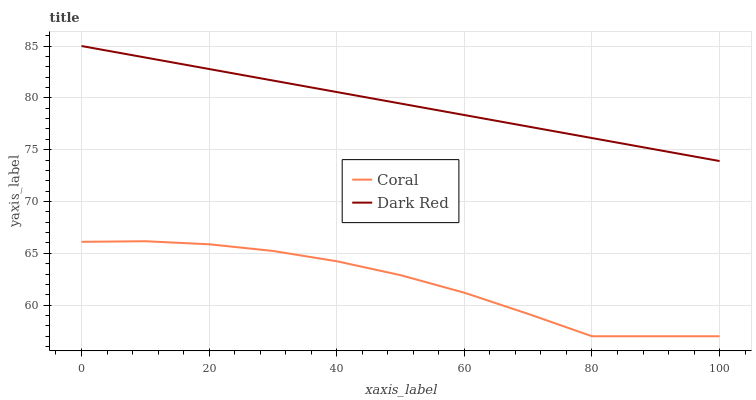Does Coral have the minimum area under the curve?
Answer yes or no. Yes. Does Dark Red have the maximum area under the curve?
Answer yes or no. Yes. Does Coral have the maximum area under the curve?
Answer yes or no. No. Is Dark Red the smoothest?
Answer yes or no. Yes. Is Coral the roughest?
Answer yes or no. Yes. Is Coral the smoothest?
Answer yes or no. No. Does Coral have the lowest value?
Answer yes or no. Yes. Does Dark Red have the highest value?
Answer yes or no. Yes. Does Coral have the highest value?
Answer yes or no. No. Is Coral less than Dark Red?
Answer yes or no. Yes. Is Dark Red greater than Coral?
Answer yes or no. Yes. Does Coral intersect Dark Red?
Answer yes or no. No. 